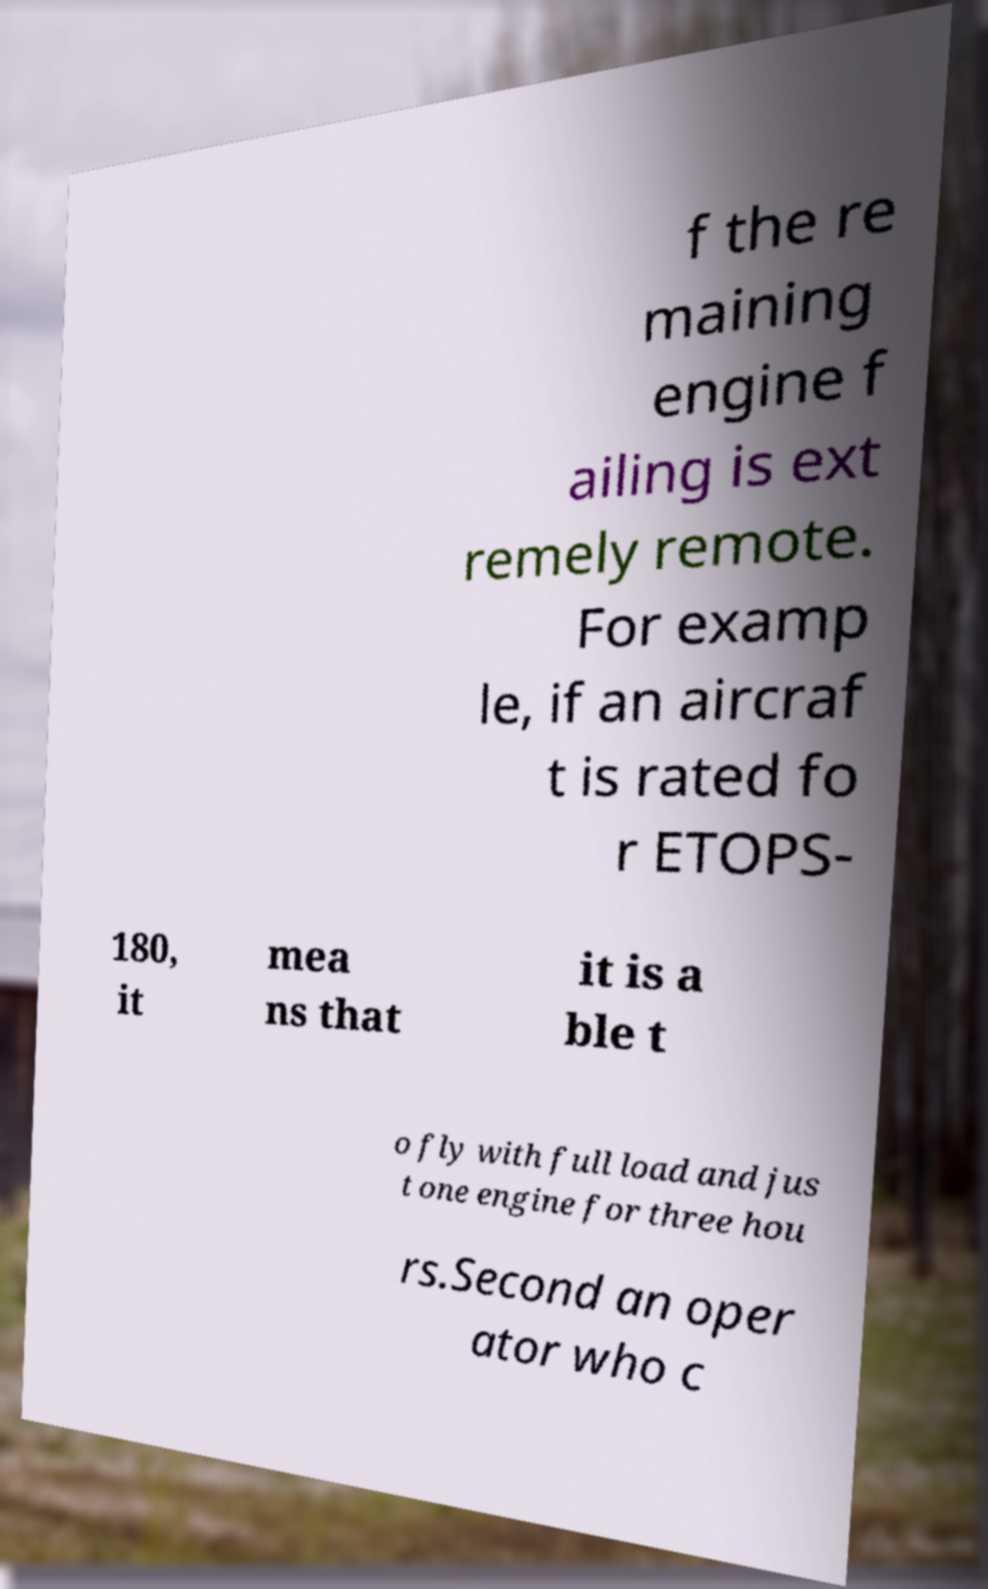For documentation purposes, I need the text within this image transcribed. Could you provide that? f the re maining engine f ailing is ext remely remote. For examp le, if an aircraf t is rated fo r ETOPS- 180, it mea ns that it is a ble t o fly with full load and jus t one engine for three hou rs.Second an oper ator who c 